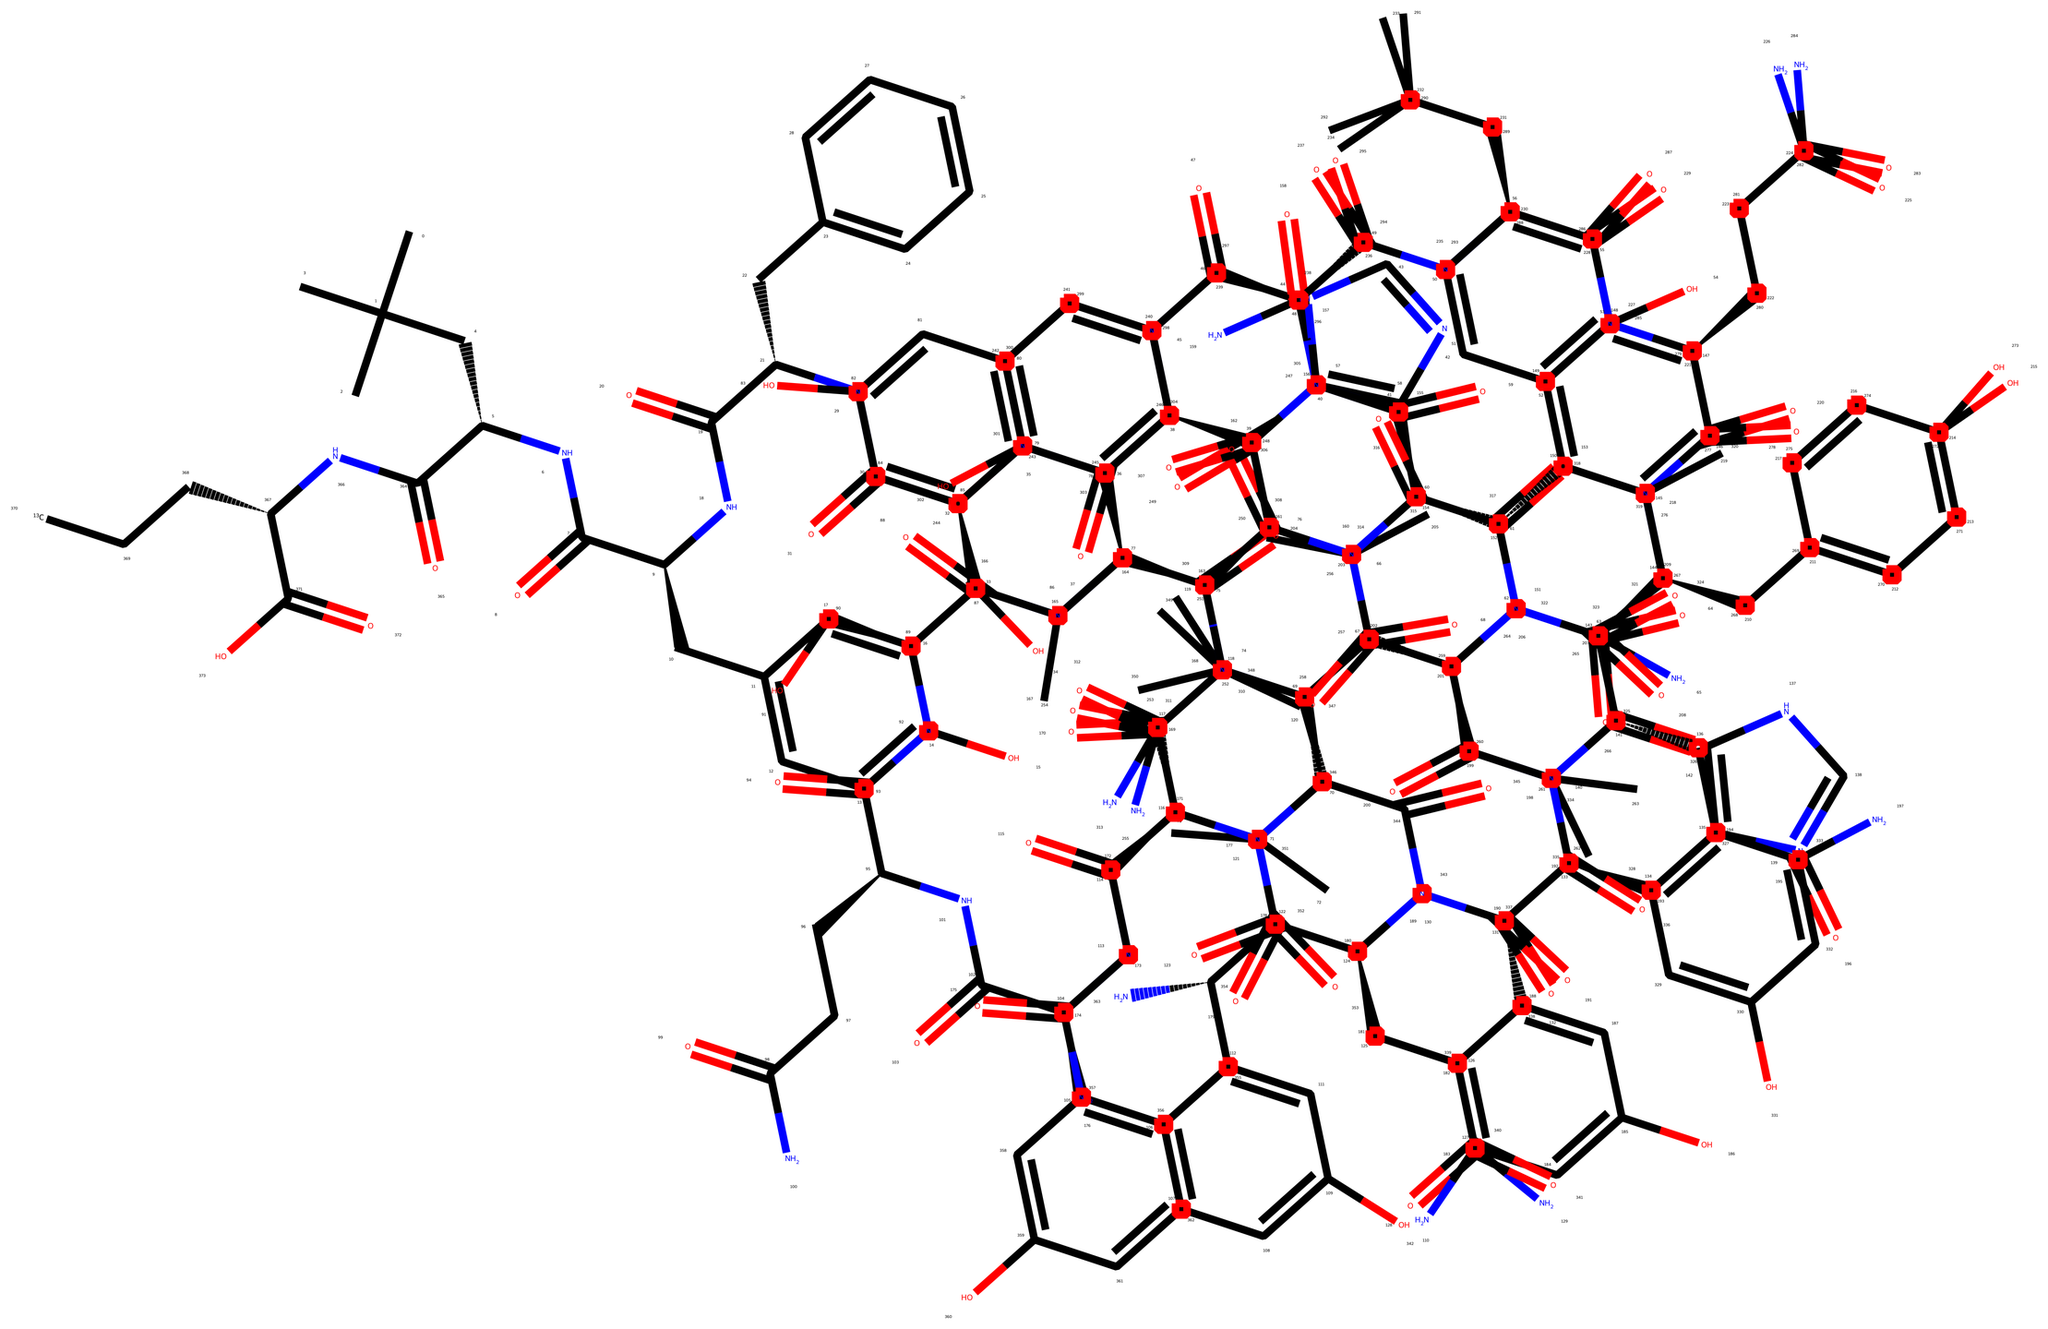What is the main functional group present in this compound? The compound contains multiple amide bonds, which can be identified by the presence of carbonyl (C=O) groups directly connected to nitrogen atoms (–N). This is a characteristic feature of amides.
Answer: amide How many carbon atoms are present in the carbon-13 labeled segment of the molecule? The carbon-13 labeled segment is indicated by the presence of a specific label, [13CH3], which signifies one carbon atom with the isotope Carbon-13. Additionally, there are other carbon atoms in the main structure without the isotope designation. Counting the carbon atoms specifically tied to the label yields a total of 1 for Carbon-13.
Answer: 1 What type of bonding is primarily responsible for the structure of the peptide linkage? The structure contains peptide bonds formed from the reaction between the carboxyl group of one amino acid and the amino group of another, resulting in covalent bonds (–C(=O)–NH–) that link the amino acids together.
Answer: covalent How many nitrogen atoms are found in the overall structure? By analyzing the structure within the SMILES representation, we can count the nitrogen atoms marked as "N." The total number in the compound is identified as there are several amide linkages, which contribute to a total of 10 nitrogen atoms overall.
Answer: 10 What role does the carbon-13 label play in Alzheimer's research? The carbon-13 labeled carbon atoms are used in nuclear magnetic resonance (NMR) spectroscopy. This technique allows researchers to trace the metabolism and interactions of the amyloid-beta peptide in biological systems, which is particularly valuable in Alzheimer’s research for understanding disease mechanisms.
Answer: NMR spectroscopy 